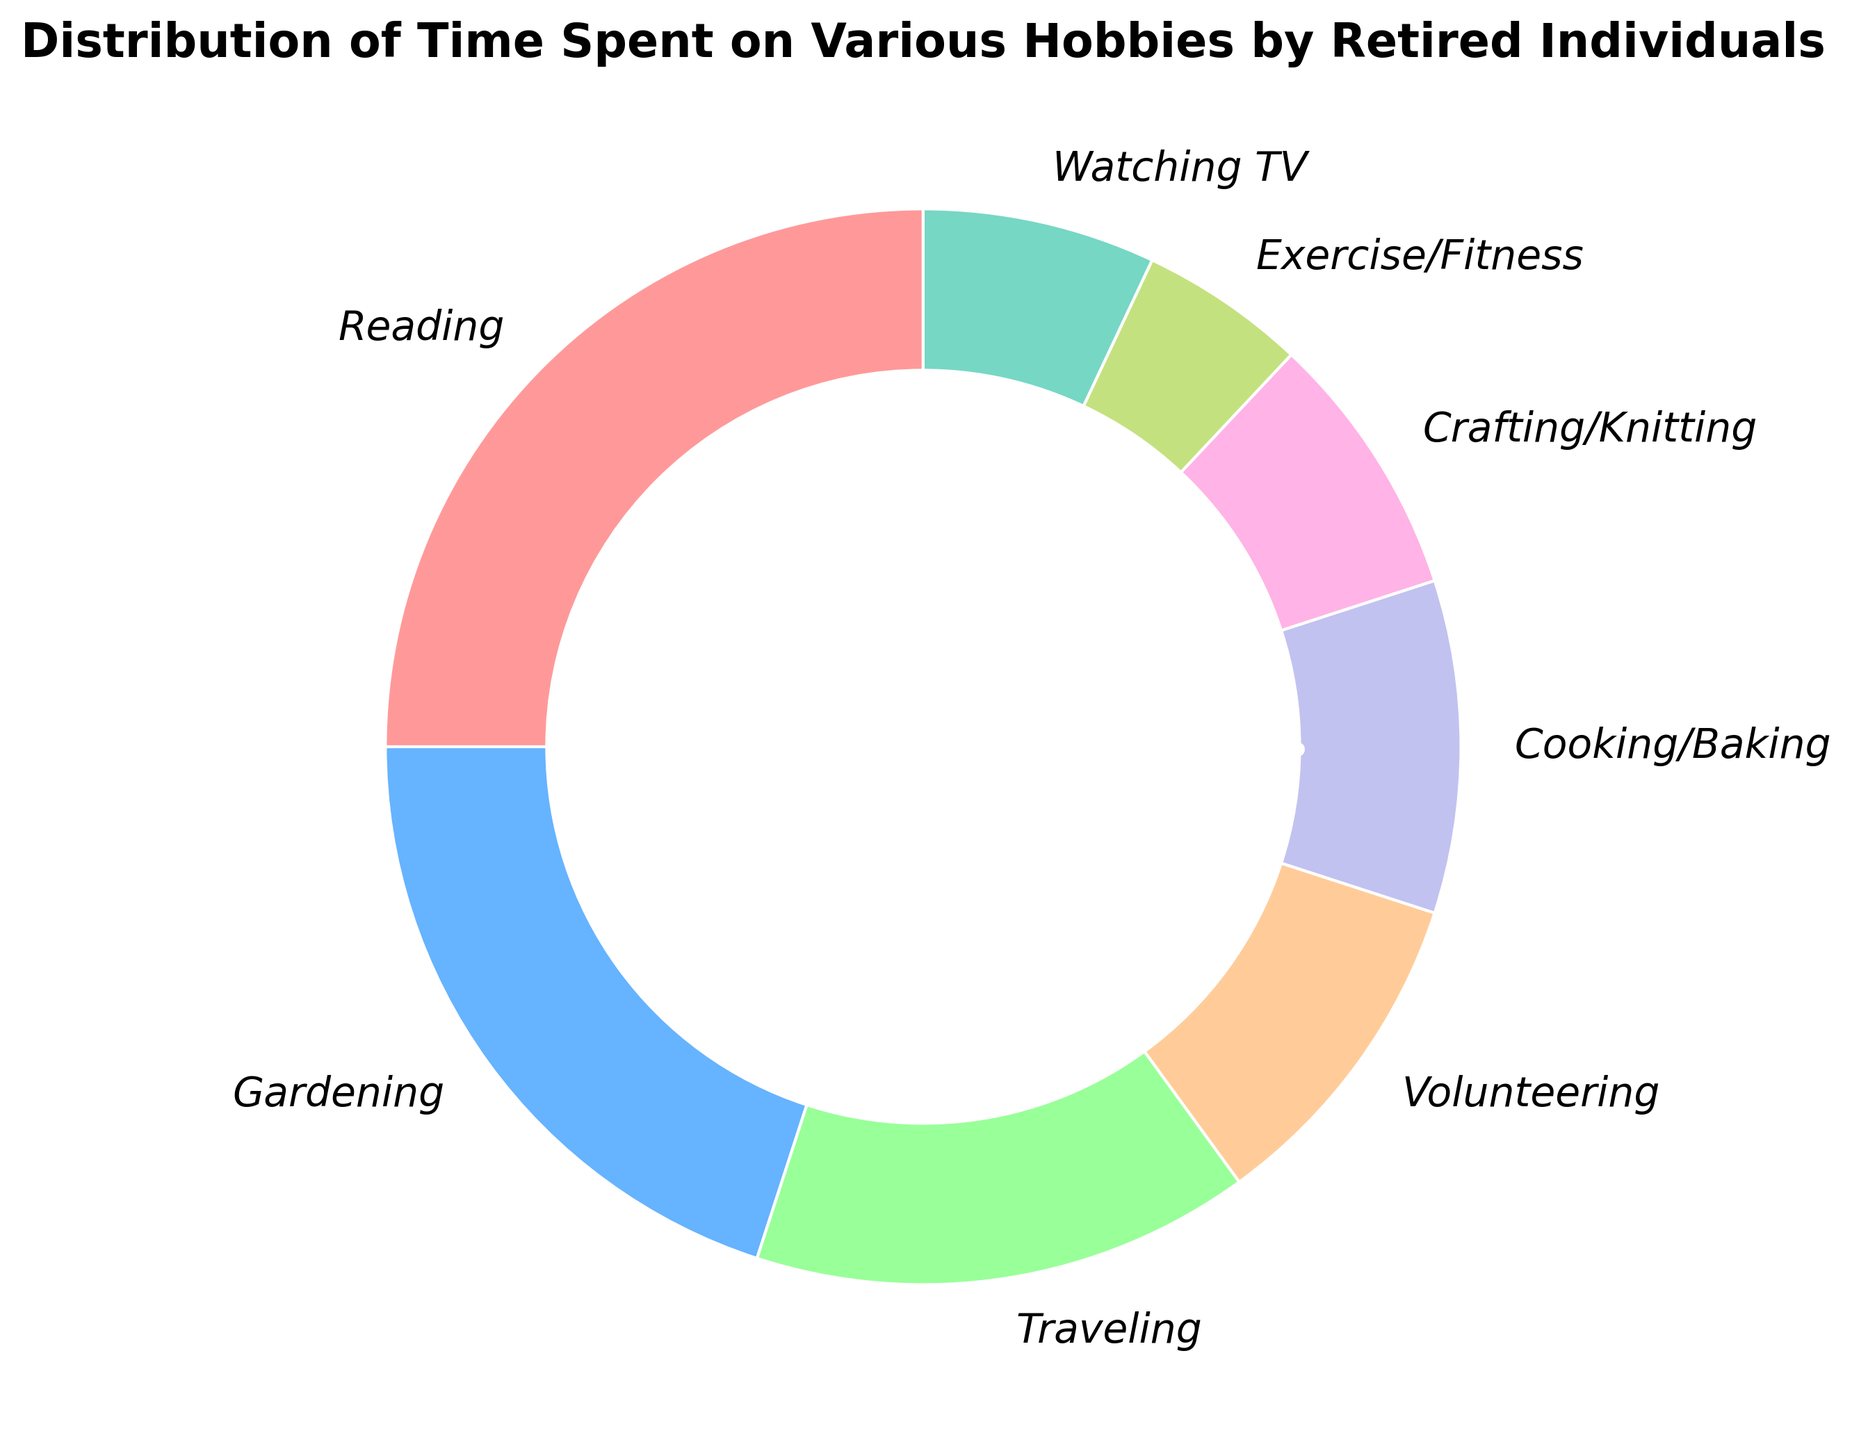Which hobby takes up the largest percentage of time? The hobby with the highest percentage in the pie chart is the largest section. In the figure, reading takes up the largest percentage at 25%.
Answer: Reading Which hobbies together account for exactly half of the time spent on hobbies? To find the two hobbies that sum to 50%, we look for percentages that add up to 50. Reading (25%) and Gardening (20%) together cover 45%, and adding Traveling (15%) exceeds 50%. Combining four hobbies (Reading, Gardening, Traveling, and Volunteering) covers 70%. There is no exact combination of two or three hobbies that sum exactly to 50%.
Answer: None What is the difference in percentage between Cooking/Baking and Watching TV? Cooking/Baking takes up 10% and Watching TV takes up 7%. The difference is calculated as 10% - 7%.
Answer: 3% Which hobby spends more time on average, Gardening or Volunteering? Comparing the percentages, Gardening is 20% and Volunteering is 10%. Gardening takes up more time than Volunteering.
Answer: Gardening If someone spends 2 hours on Exercise/Fitness, how many hours would they spend proportionally on Crafting/Knitting? Exercise/Fitness = 5%, Crafting/Knitting = 8%. Proportional relationship is 8/5. So for every 2 hours on Exercise/Fitness, it is (8/5) * 2 = 3.2 hours on Crafting/Knitting.
Answer: 3.2 hours Among Cooking/Baking, Crafting/Knitting, and Watching TV, which hobby takes up the smallest percentage of time? Comparing the percentages: Cooking/Baking 10%, Crafting/Knitting 8%, Watching TV 7%. Watching TV takes the smallest percentage.
Answer: Watching TV How much more time do individuals spend on Gardening compared to Exercise/Fitness? Gardening is 20% and Exercise/Fitness is 5%. The difference is calculated as 20% - 5%.
Answer: 15% If an individual allocates 4 hours to Reading, how much time would they spend on Gardening proportionally? Reading = 25%, Gardening = 20%. Proportional relationship is 20/25. So for every 4 hours on Reading, it is (20/25) * 4 = 3.2 hours on Gardening.
Answer: 3.2 hours How do the proportions of time spent on Traveling and Cooking/Baking compare visually? Traveling has a 15% slice and Cooking/Baking has a 10% slice. By comparing their sizes, Traveling has a larger slice than Cooking/Baking.
Answer: Traveling is larger What is the total percentage of time spent on Crafting/Knitting and Watching TV? Crafting/Knitting is 8% and Watching TV is 7%. The sum is calculated as 8% + 7%.
Answer: 15% 